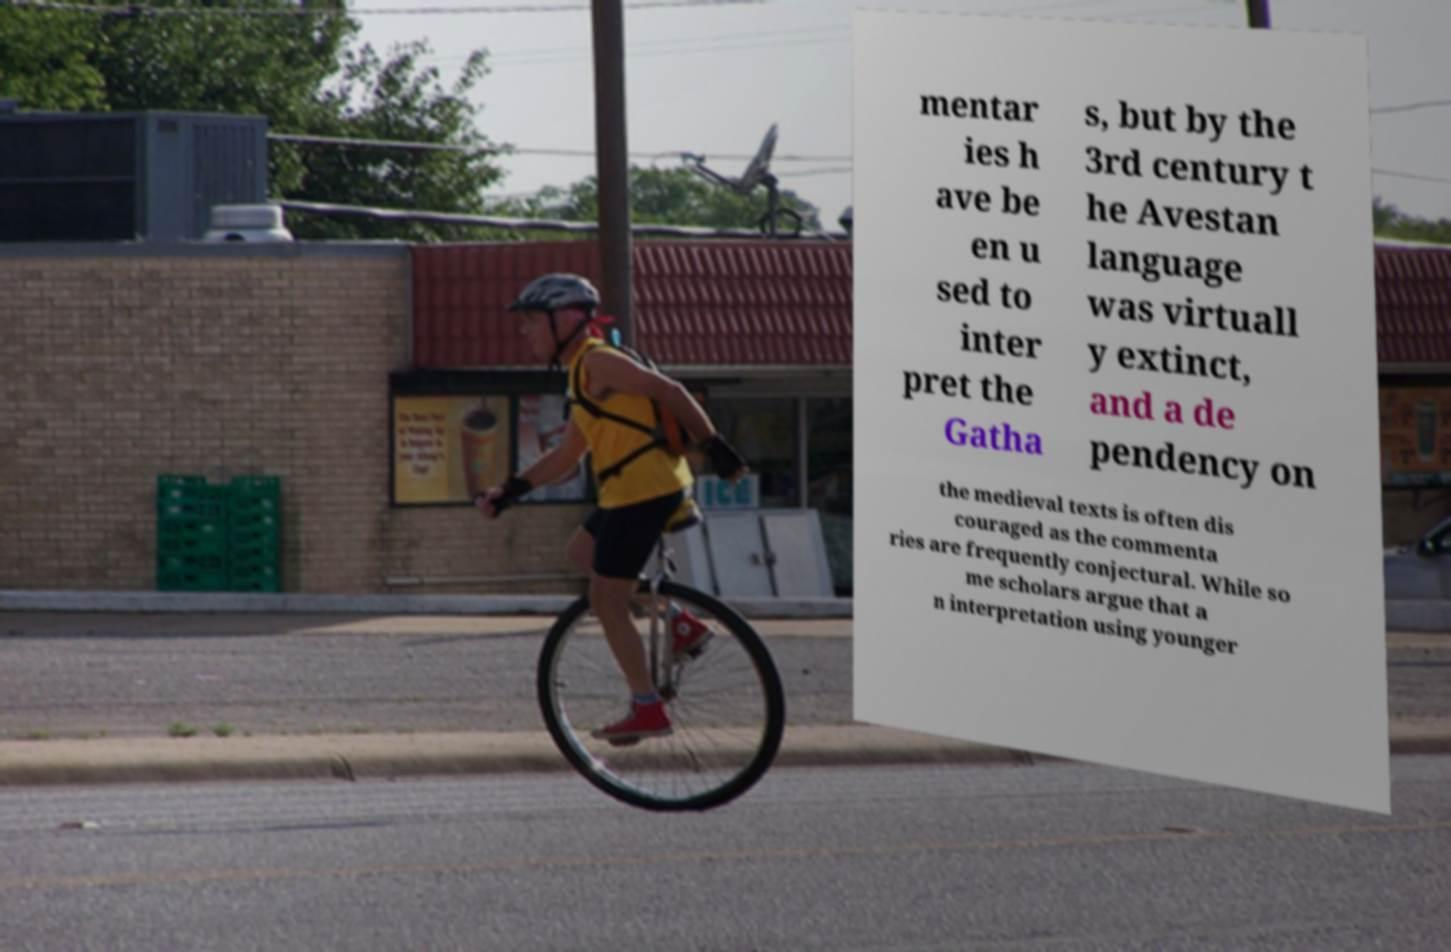Please read and relay the text visible in this image. What does it say? mentar ies h ave be en u sed to inter pret the Gatha s, but by the 3rd century t he Avestan language was virtuall y extinct, and a de pendency on the medieval texts is often dis couraged as the commenta ries are frequently conjectural. While so me scholars argue that a n interpretation using younger 